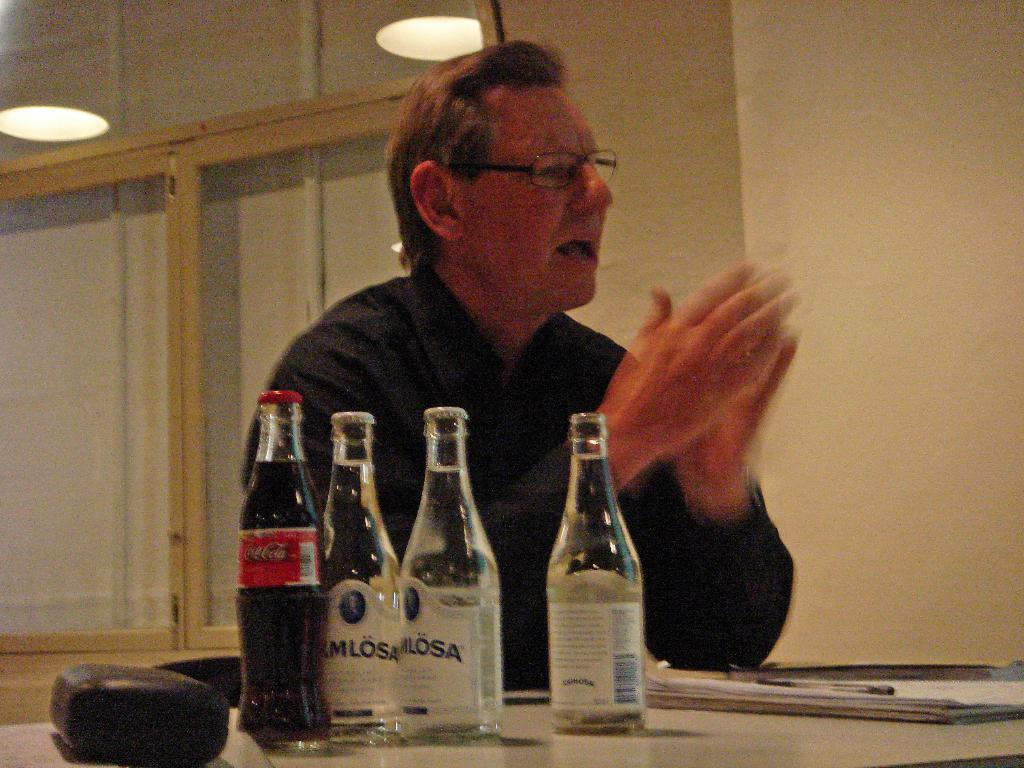<image>
Offer a succinct explanation of the picture presented. A man sits at a table with 3 bottles of water and a Coca Cola bottle near him. 